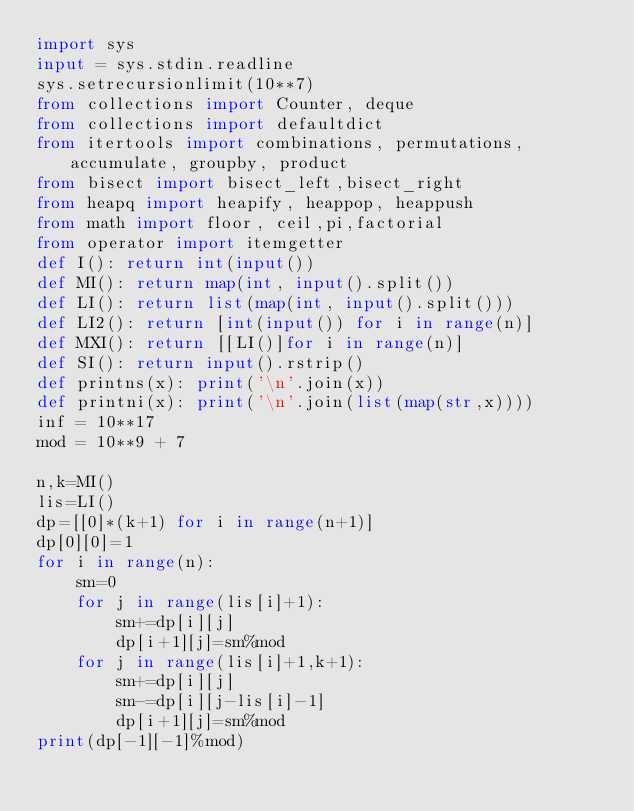Convert code to text. <code><loc_0><loc_0><loc_500><loc_500><_Python_>import sys
input = sys.stdin.readline
sys.setrecursionlimit(10**7)
from collections import Counter, deque
from collections import defaultdict
from itertools import combinations, permutations, accumulate, groupby, product
from bisect import bisect_left,bisect_right
from heapq import heapify, heappop, heappush
from math import floor, ceil,pi,factorial
from operator import itemgetter
def I(): return int(input())
def MI(): return map(int, input().split())
def LI(): return list(map(int, input().split()))
def LI2(): return [int(input()) for i in range(n)]
def MXI(): return [[LI()]for i in range(n)]
def SI(): return input().rstrip()
def printns(x): print('\n'.join(x))
def printni(x): print('\n'.join(list(map(str,x))))
inf = 10**17
mod = 10**9 + 7

n,k=MI()
lis=LI()
dp=[[0]*(k+1) for i in range(n+1)]
dp[0][0]=1
for i in range(n):
    sm=0
    for j in range(lis[i]+1):
        sm+=dp[i][j]
        dp[i+1][j]=sm%mod
    for j in range(lis[i]+1,k+1):
        sm+=dp[i][j]
        sm-=dp[i][j-lis[i]-1]
        dp[i+1][j]=sm%mod
print(dp[-1][-1]%mod)            
        
    
</code> 